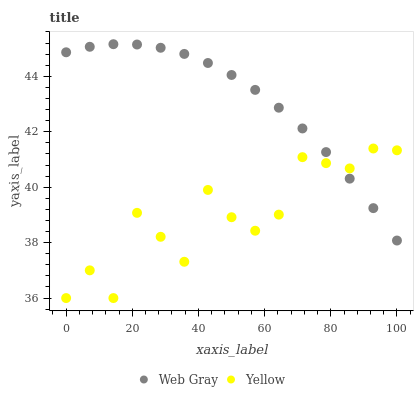Does Yellow have the minimum area under the curve?
Answer yes or no. Yes. Does Web Gray have the maximum area under the curve?
Answer yes or no. Yes. Does Yellow have the maximum area under the curve?
Answer yes or no. No. Is Web Gray the smoothest?
Answer yes or no. Yes. Is Yellow the roughest?
Answer yes or no. Yes. Is Yellow the smoothest?
Answer yes or no. No. Does Yellow have the lowest value?
Answer yes or no. Yes. Does Web Gray have the highest value?
Answer yes or no. Yes. Does Yellow have the highest value?
Answer yes or no. No. Does Web Gray intersect Yellow?
Answer yes or no. Yes. Is Web Gray less than Yellow?
Answer yes or no. No. Is Web Gray greater than Yellow?
Answer yes or no. No. 